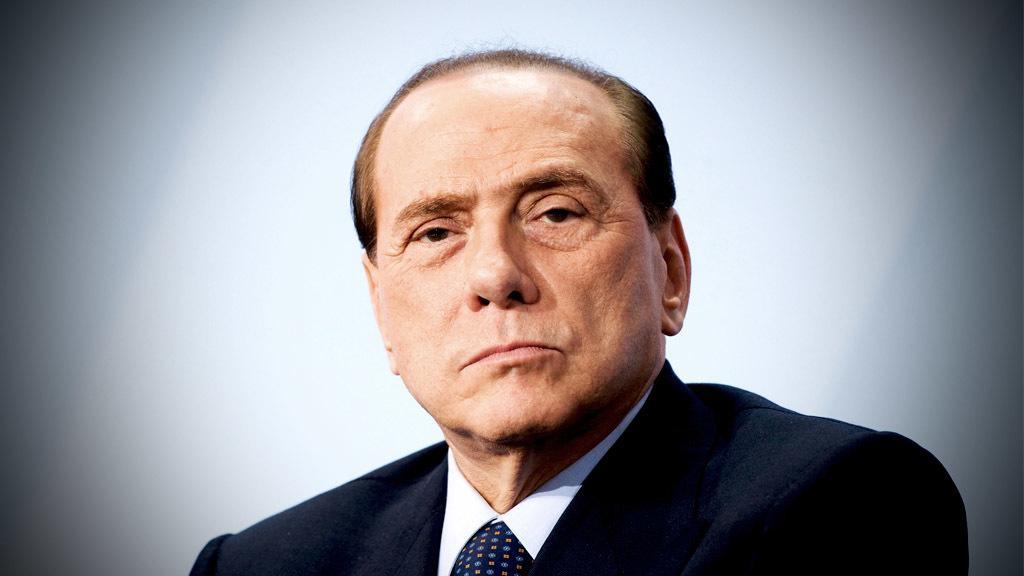Could you give a brief overview of what you see in this image? In this picture we can see a man in a blazer. Behind the man, there is a white background. 